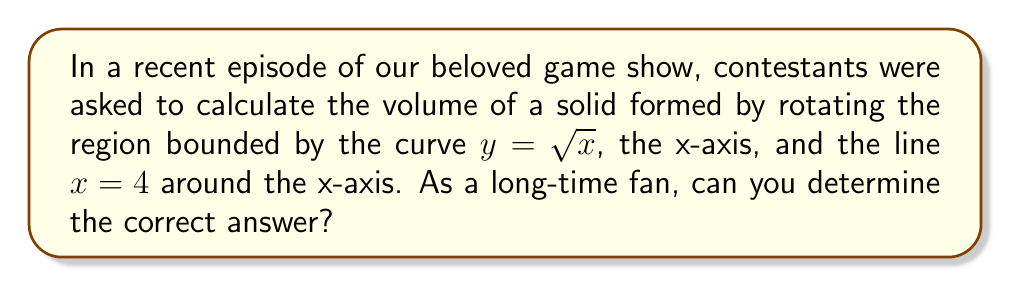Help me with this question. Let's approach this step-by-step:

1) To find the volume of a solid formed by rotating a region around the x-axis, we use the disk method. The formula is:

   $$V = \pi \int_a^b [f(x)]^2 dx$$

   where $f(x)$ is the function, and $a$ and $b$ are the limits of integration.

2) In this case, $f(x) = \sqrt{x}$, $a = 0$, and $b = 4$.

3) Substituting these into our formula:

   $$V = \pi \int_0^4 (\sqrt{x})^2 dx$$

4) Simplify the integrand:

   $$V = \pi \int_0^4 x dx$$

5) Integrate:

   $$V = \pi [\frac{1}{2}x^2]_0^4$$

6) Evaluate the integral:

   $$V = \pi [\frac{1}{2}(4^2) - \frac{1}{2}(0^2)]$$
   $$V = \pi [8 - 0]$$
   $$V = 8\pi$$

7) Therefore, the volume of the solid is $8\pi$ cubic units.
Answer: $8\pi$ cubic units 